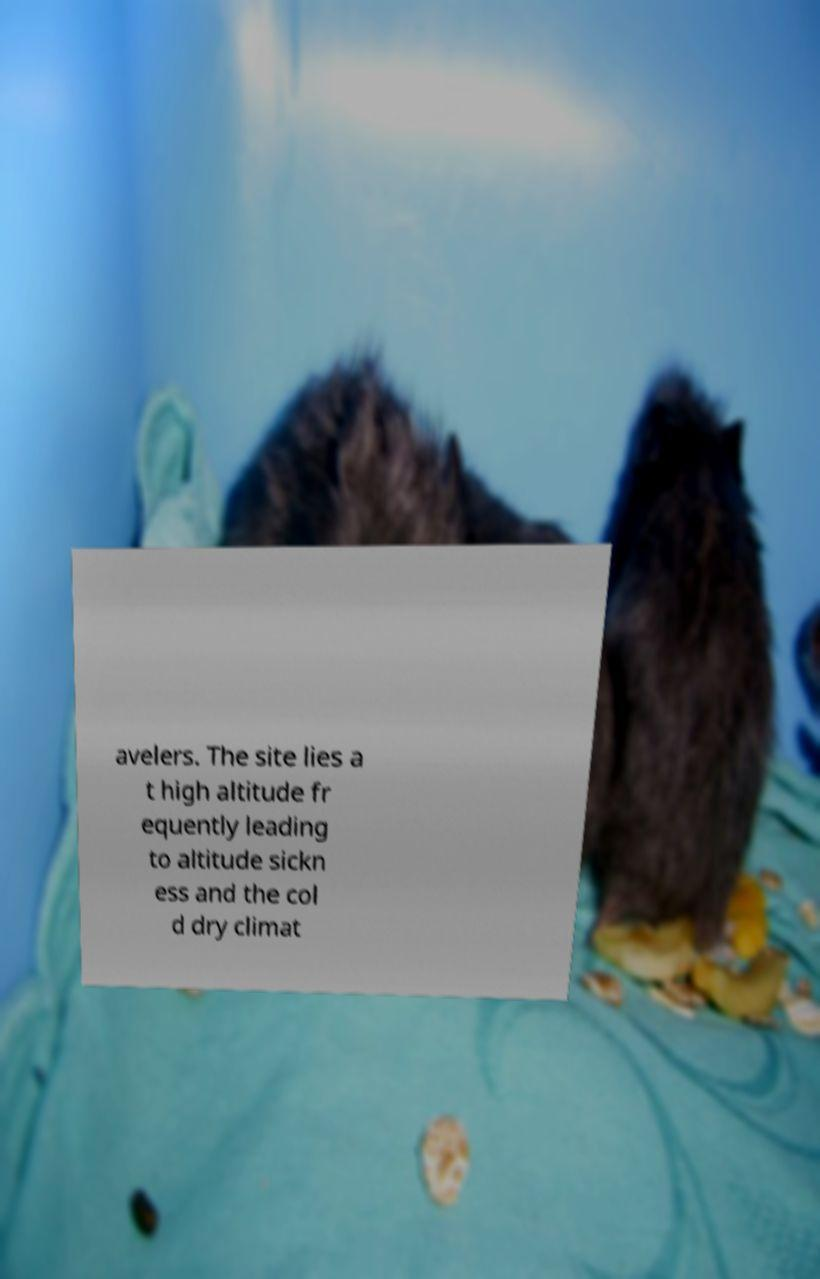Can you read and provide the text displayed in the image?This photo seems to have some interesting text. Can you extract and type it out for me? avelers. The site lies a t high altitude fr equently leading to altitude sickn ess and the col d dry climat 